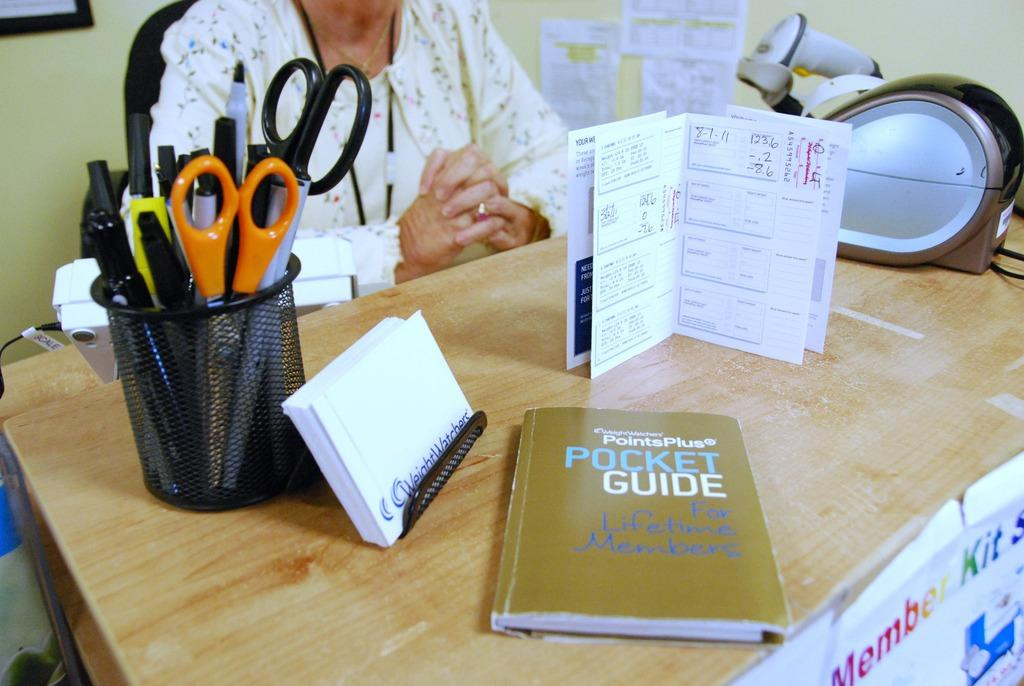What is the person in the image doing? The person is seated in the image. What is the person sitting on? The person is seated on a chair. What objects are on the table in the image? There are papers, books, scissors, and pens on the table. What type of rabbit can be seen eating a vegetable in the image? There is no rabbit or vegetable present in the image. Is the person celebrating their birthday in the image? There is no indication in the image that the person is celebrating a birthday. 